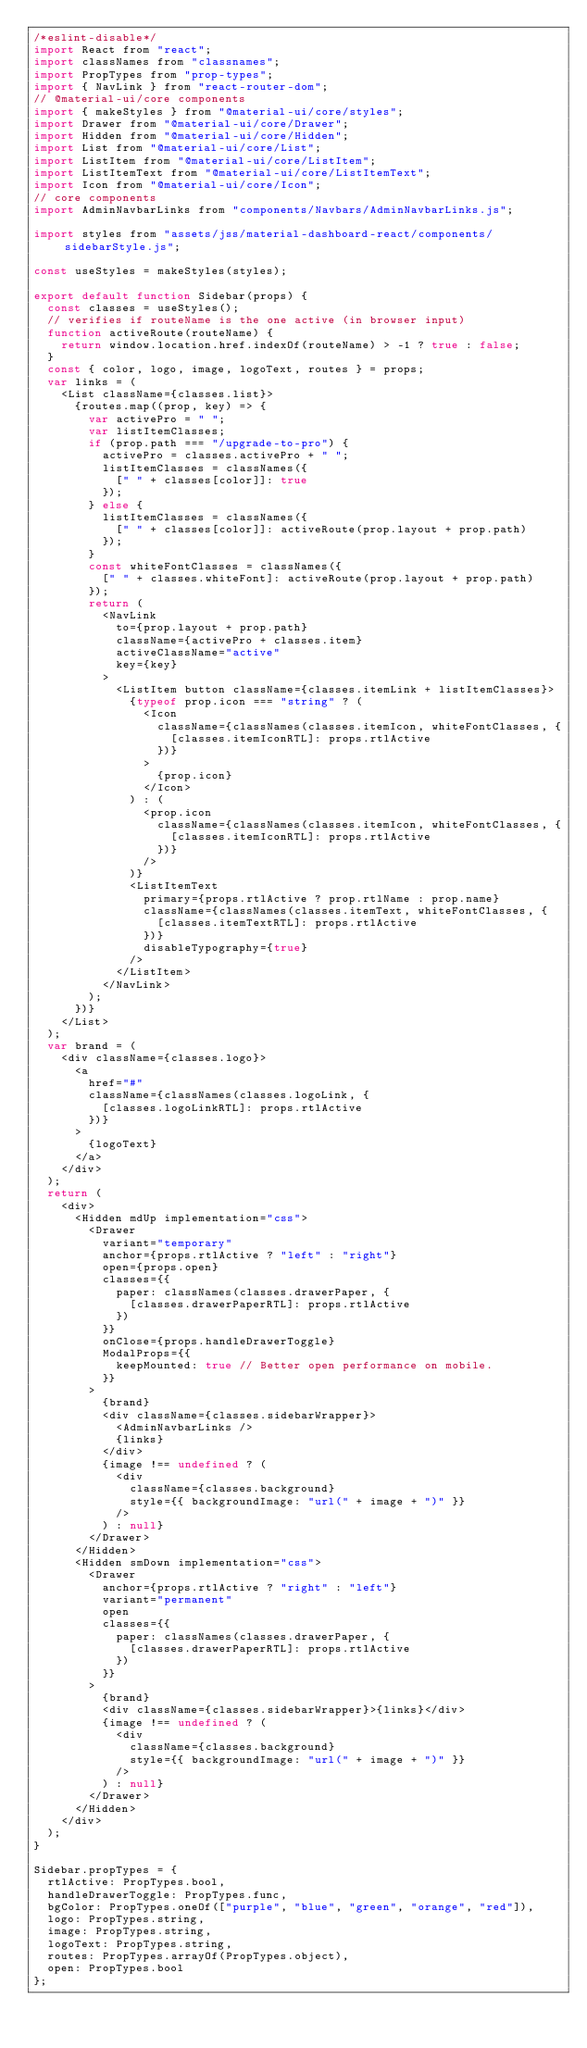Convert code to text. <code><loc_0><loc_0><loc_500><loc_500><_JavaScript_>/*eslint-disable*/
import React from "react";
import classNames from "classnames";
import PropTypes from "prop-types";
import { NavLink } from "react-router-dom";
// @material-ui/core components
import { makeStyles } from "@material-ui/core/styles";
import Drawer from "@material-ui/core/Drawer";
import Hidden from "@material-ui/core/Hidden";
import List from "@material-ui/core/List";
import ListItem from "@material-ui/core/ListItem";
import ListItemText from "@material-ui/core/ListItemText";
import Icon from "@material-ui/core/Icon";
// core components
import AdminNavbarLinks from "components/Navbars/AdminNavbarLinks.js";

import styles from "assets/jss/material-dashboard-react/components/sidebarStyle.js";

const useStyles = makeStyles(styles);

export default function Sidebar(props) {
  const classes = useStyles();
  // verifies if routeName is the one active (in browser input)
  function activeRoute(routeName) {
    return window.location.href.indexOf(routeName) > -1 ? true : false;
  }
  const { color, logo, image, logoText, routes } = props;
  var links = (
    <List className={classes.list}>
      {routes.map((prop, key) => {
        var activePro = " ";
        var listItemClasses;
        if (prop.path === "/upgrade-to-pro") {
          activePro = classes.activePro + " ";
          listItemClasses = classNames({
            [" " + classes[color]]: true
          });
        } else {
          listItemClasses = classNames({
            [" " + classes[color]]: activeRoute(prop.layout + prop.path)
          });
        }
        const whiteFontClasses = classNames({
          [" " + classes.whiteFont]: activeRoute(prop.layout + prop.path)
        });
        return (
          <NavLink
            to={prop.layout + prop.path}
            className={activePro + classes.item}
            activeClassName="active"
            key={key}
          >
            <ListItem button className={classes.itemLink + listItemClasses}>
              {typeof prop.icon === "string" ? (
                <Icon
                  className={classNames(classes.itemIcon, whiteFontClasses, {
                    [classes.itemIconRTL]: props.rtlActive
                  })}
                >
                  {prop.icon}
                </Icon>
              ) : (
                <prop.icon
                  className={classNames(classes.itemIcon, whiteFontClasses, {
                    [classes.itemIconRTL]: props.rtlActive
                  })}
                />
              )}
              <ListItemText
                primary={props.rtlActive ? prop.rtlName : prop.name}
                className={classNames(classes.itemText, whiteFontClasses, {
                  [classes.itemTextRTL]: props.rtlActive
                })}
                disableTypography={true}
              />
            </ListItem>
          </NavLink>
        );
      })}
    </List>
  );
  var brand = (
    <div className={classes.logo}>
      <a
        href="#"
        className={classNames(classes.logoLink, {
          [classes.logoLinkRTL]: props.rtlActive
        })}
      >
        {logoText}
      </a>
    </div>
  );
  return (
    <div>
      <Hidden mdUp implementation="css">
        <Drawer
          variant="temporary"
          anchor={props.rtlActive ? "left" : "right"}
          open={props.open}
          classes={{
            paper: classNames(classes.drawerPaper, {
              [classes.drawerPaperRTL]: props.rtlActive
            })
          }}
          onClose={props.handleDrawerToggle}
          ModalProps={{
            keepMounted: true // Better open performance on mobile.
          }}
        >
          {brand}
          <div className={classes.sidebarWrapper}>
            <AdminNavbarLinks />
            {links}
          </div>
          {image !== undefined ? (
            <div
              className={classes.background}
              style={{ backgroundImage: "url(" + image + ")" }}
            />
          ) : null}
        </Drawer>
      </Hidden>
      <Hidden smDown implementation="css">
        <Drawer
          anchor={props.rtlActive ? "right" : "left"}
          variant="permanent"
          open
          classes={{
            paper: classNames(classes.drawerPaper, {
              [classes.drawerPaperRTL]: props.rtlActive
            })
          }}
        >
          {brand}
          <div className={classes.sidebarWrapper}>{links}</div>
          {image !== undefined ? (
            <div
              className={classes.background}
              style={{ backgroundImage: "url(" + image + ")" }}
            />
          ) : null}
        </Drawer>
      </Hidden>
    </div>
  );
}

Sidebar.propTypes = {
  rtlActive: PropTypes.bool,
  handleDrawerToggle: PropTypes.func,
  bgColor: PropTypes.oneOf(["purple", "blue", "green", "orange", "red"]),
  logo: PropTypes.string,
  image: PropTypes.string,
  logoText: PropTypes.string,
  routes: PropTypes.arrayOf(PropTypes.object),
  open: PropTypes.bool
};
</code> 